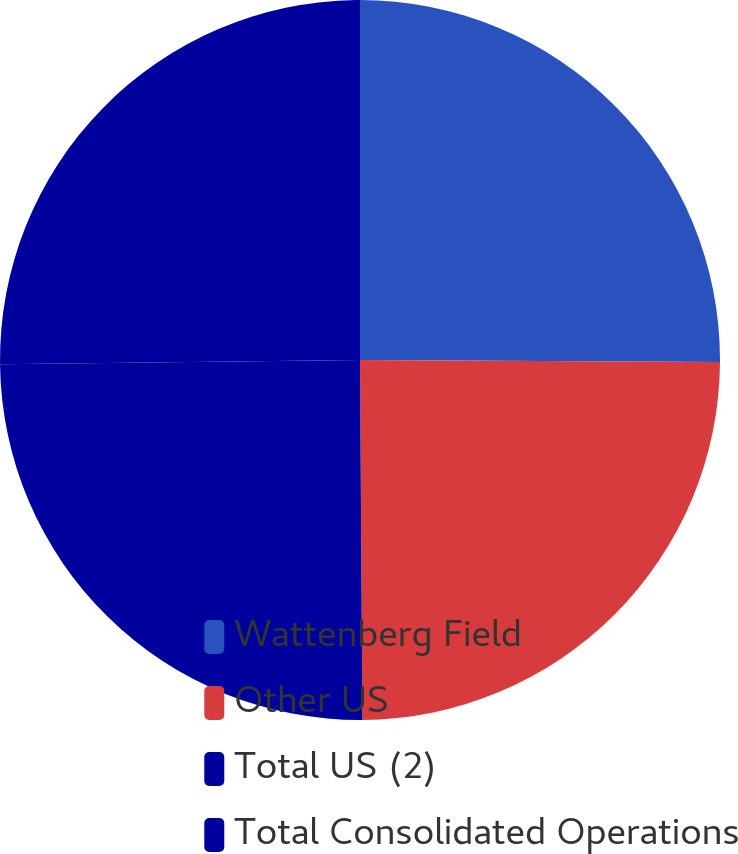Convert chart. <chart><loc_0><loc_0><loc_500><loc_500><pie_chart><fcel>Wattenberg Field<fcel>Other US<fcel>Total US (2)<fcel>Total Consolidated Operations<nl><fcel>25.09%<fcel>24.8%<fcel>24.92%<fcel>25.18%<nl></chart> 